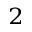Convert formula to latex. <formula><loc_0><loc_0><loc_500><loc_500>^ { 2 }</formula> 